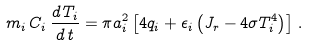<formula> <loc_0><loc_0><loc_500><loc_500>m _ { i } \, C _ { i } \, \frac { d \, T _ { i } } { d \, t } = \pi a _ { i } ^ { 2 } \left [ 4 q _ { i } + \epsilon _ { i } \left ( J _ { r } - 4 \sigma T _ { i } ^ { 4 } \right ) \right ] \, .</formula> 